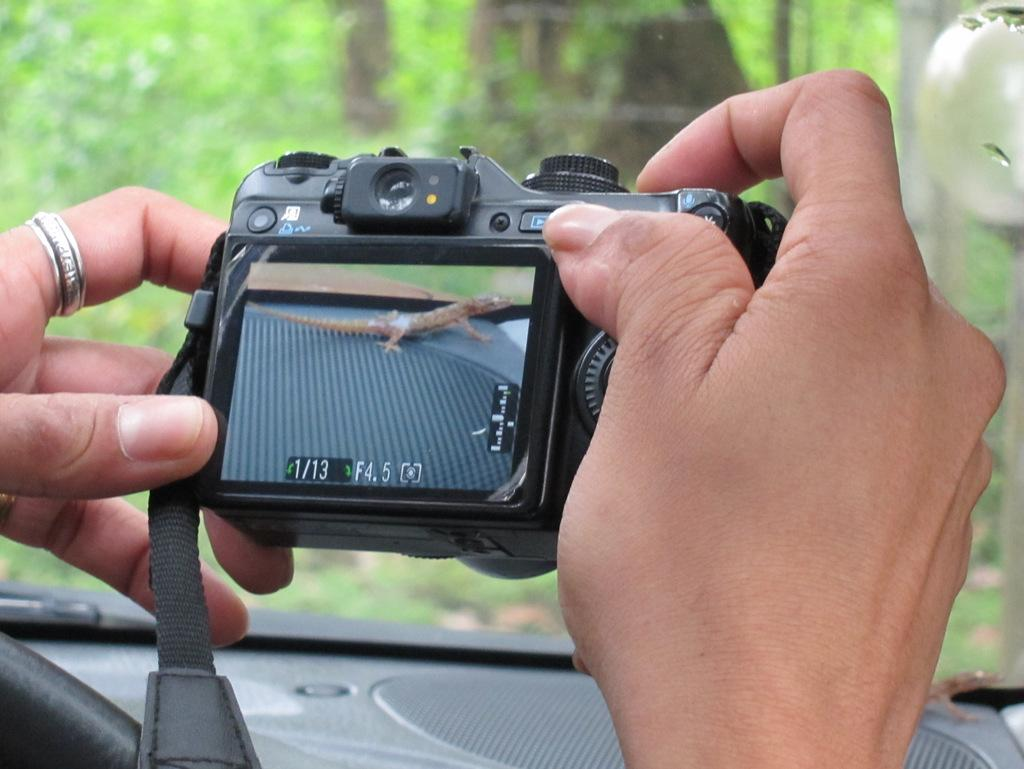<image>
Present a compact description of the photo's key features. A camera with a lizard on the screen and at the bottom says 1/13 F4.5. 